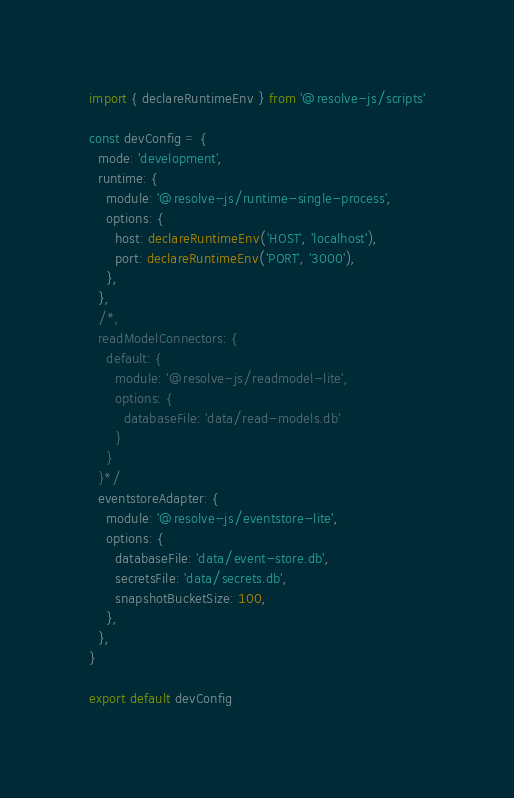Convert code to text. <code><loc_0><loc_0><loc_500><loc_500><_TypeScript_>import { declareRuntimeEnv } from '@resolve-js/scripts'

const devConfig = {
  mode: 'development',
  runtime: {
    module: '@resolve-js/runtime-single-process',
    options: {
      host: declareRuntimeEnv('HOST', 'localhost'),
      port: declareRuntimeEnv('PORT', '3000'),
    },
  },
  /*,
  readModelConnectors: {
    default: {
      module: '@resolve-js/readmodel-lite',
      options: {
        databaseFile: 'data/read-models.db'
      }
    }
  }*/
  eventstoreAdapter: {
    module: '@resolve-js/eventstore-lite',
    options: {
      databaseFile: 'data/event-store.db',
      secretsFile: 'data/secrets.db',
      snapshotBucketSize: 100,
    },
  },
}

export default devConfig
</code> 